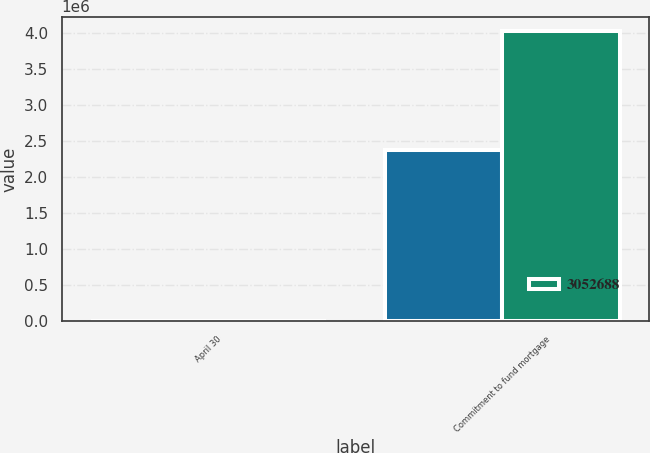<chart> <loc_0><loc_0><loc_500><loc_500><stacked_bar_chart><ecel><fcel>April 30<fcel>Commitment to fund mortgage<nl><fcel>nan<fcel>2007<fcel>2.37494e+06<nl><fcel>3.05269e+06<fcel>2006<fcel>4.03204e+06<nl></chart> 